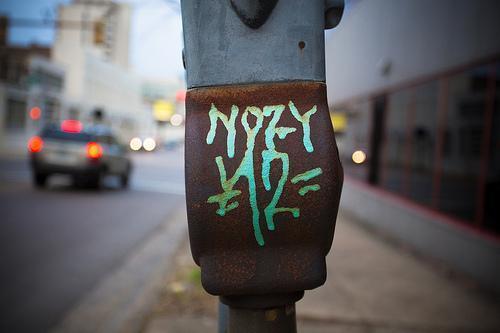How many of the characters are numbers?
Give a very brief answer. 1. 